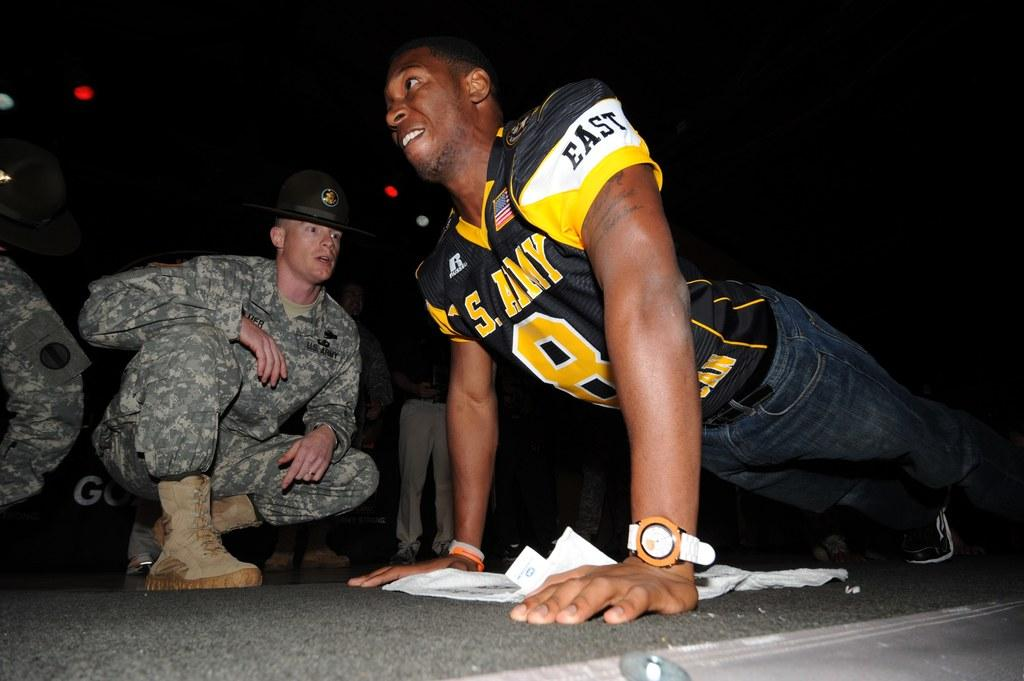Provide a one-sentence caption for the provided image. Two men, one of them doing a push up who has the word East on his sleeve. 